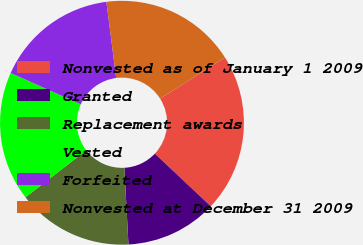Convert chart. <chart><loc_0><loc_0><loc_500><loc_500><pie_chart><fcel>Nonvested as of January 1 2009<fcel>Granted<fcel>Replacement awards<fcel>Vested<fcel>Forfeited<fcel>Nonvested at December 31 2009<nl><fcel>21.0%<fcel>12.14%<fcel>15.38%<fcel>17.16%<fcel>16.27%<fcel>18.05%<nl></chart> 